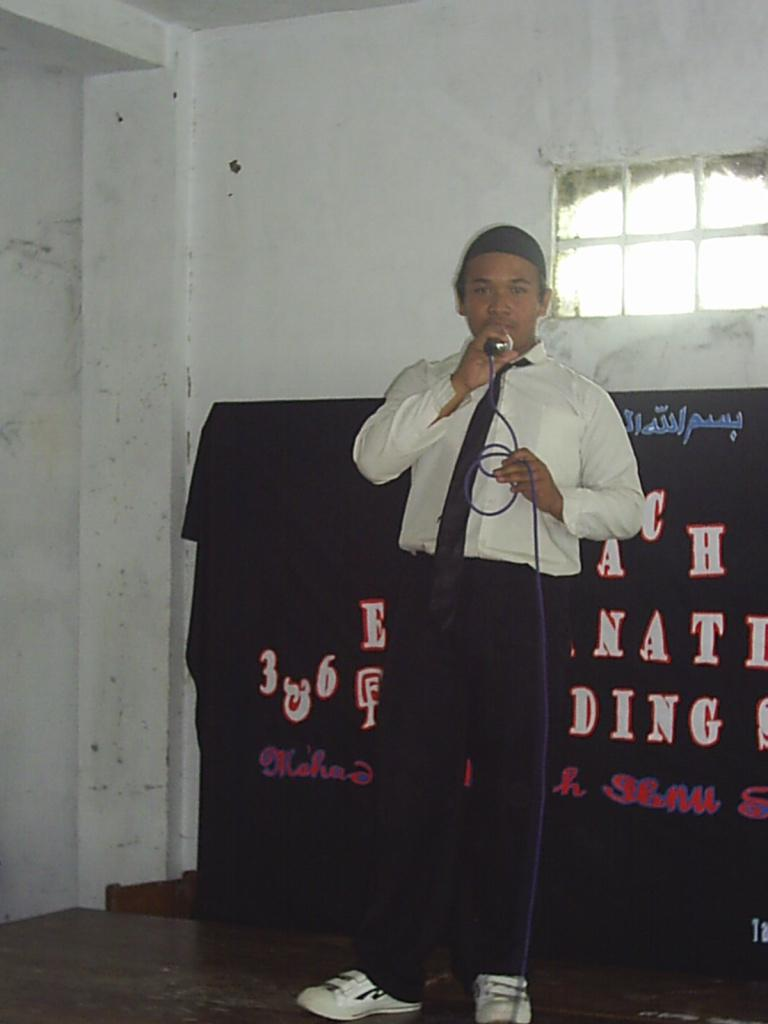Who is the main subject in the image? There is a man in the image. What is the man holding in the image? The man is holding a microphone. What else can be seen in the background of the image? There is text visible behind the man. What type of hook is the man using to hold the microphone in the image? There is no hook present in the image; the man is simply holding the microphone. What kind of station is the man operating in the image? There is no indication of a station in the image; it only shows a man holding a microphone. 